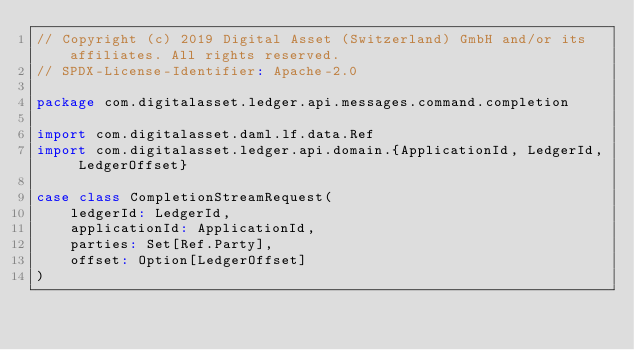Convert code to text. <code><loc_0><loc_0><loc_500><loc_500><_Scala_>// Copyright (c) 2019 Digital Asset (Switzerland) GmbH and/or its affiliates. All rights reserved.
// SPDX-License-Identifier: Apache-2.0

package com.digitalasset.ledger.api.messages.command.completion

import com.digitalasset.daml.lf.data.Ref
import com.digitalasset.ledger.api.domain.{ApplicationId, LedgerId, LedgerOffset}

case class CompletionStreamRequest(
    ledgerId: LedgerId,
    applicationId: ApplicationId,
    parties: Set[Ref.Party],
    offset: Option[LedgerOffset]
)
</code> 